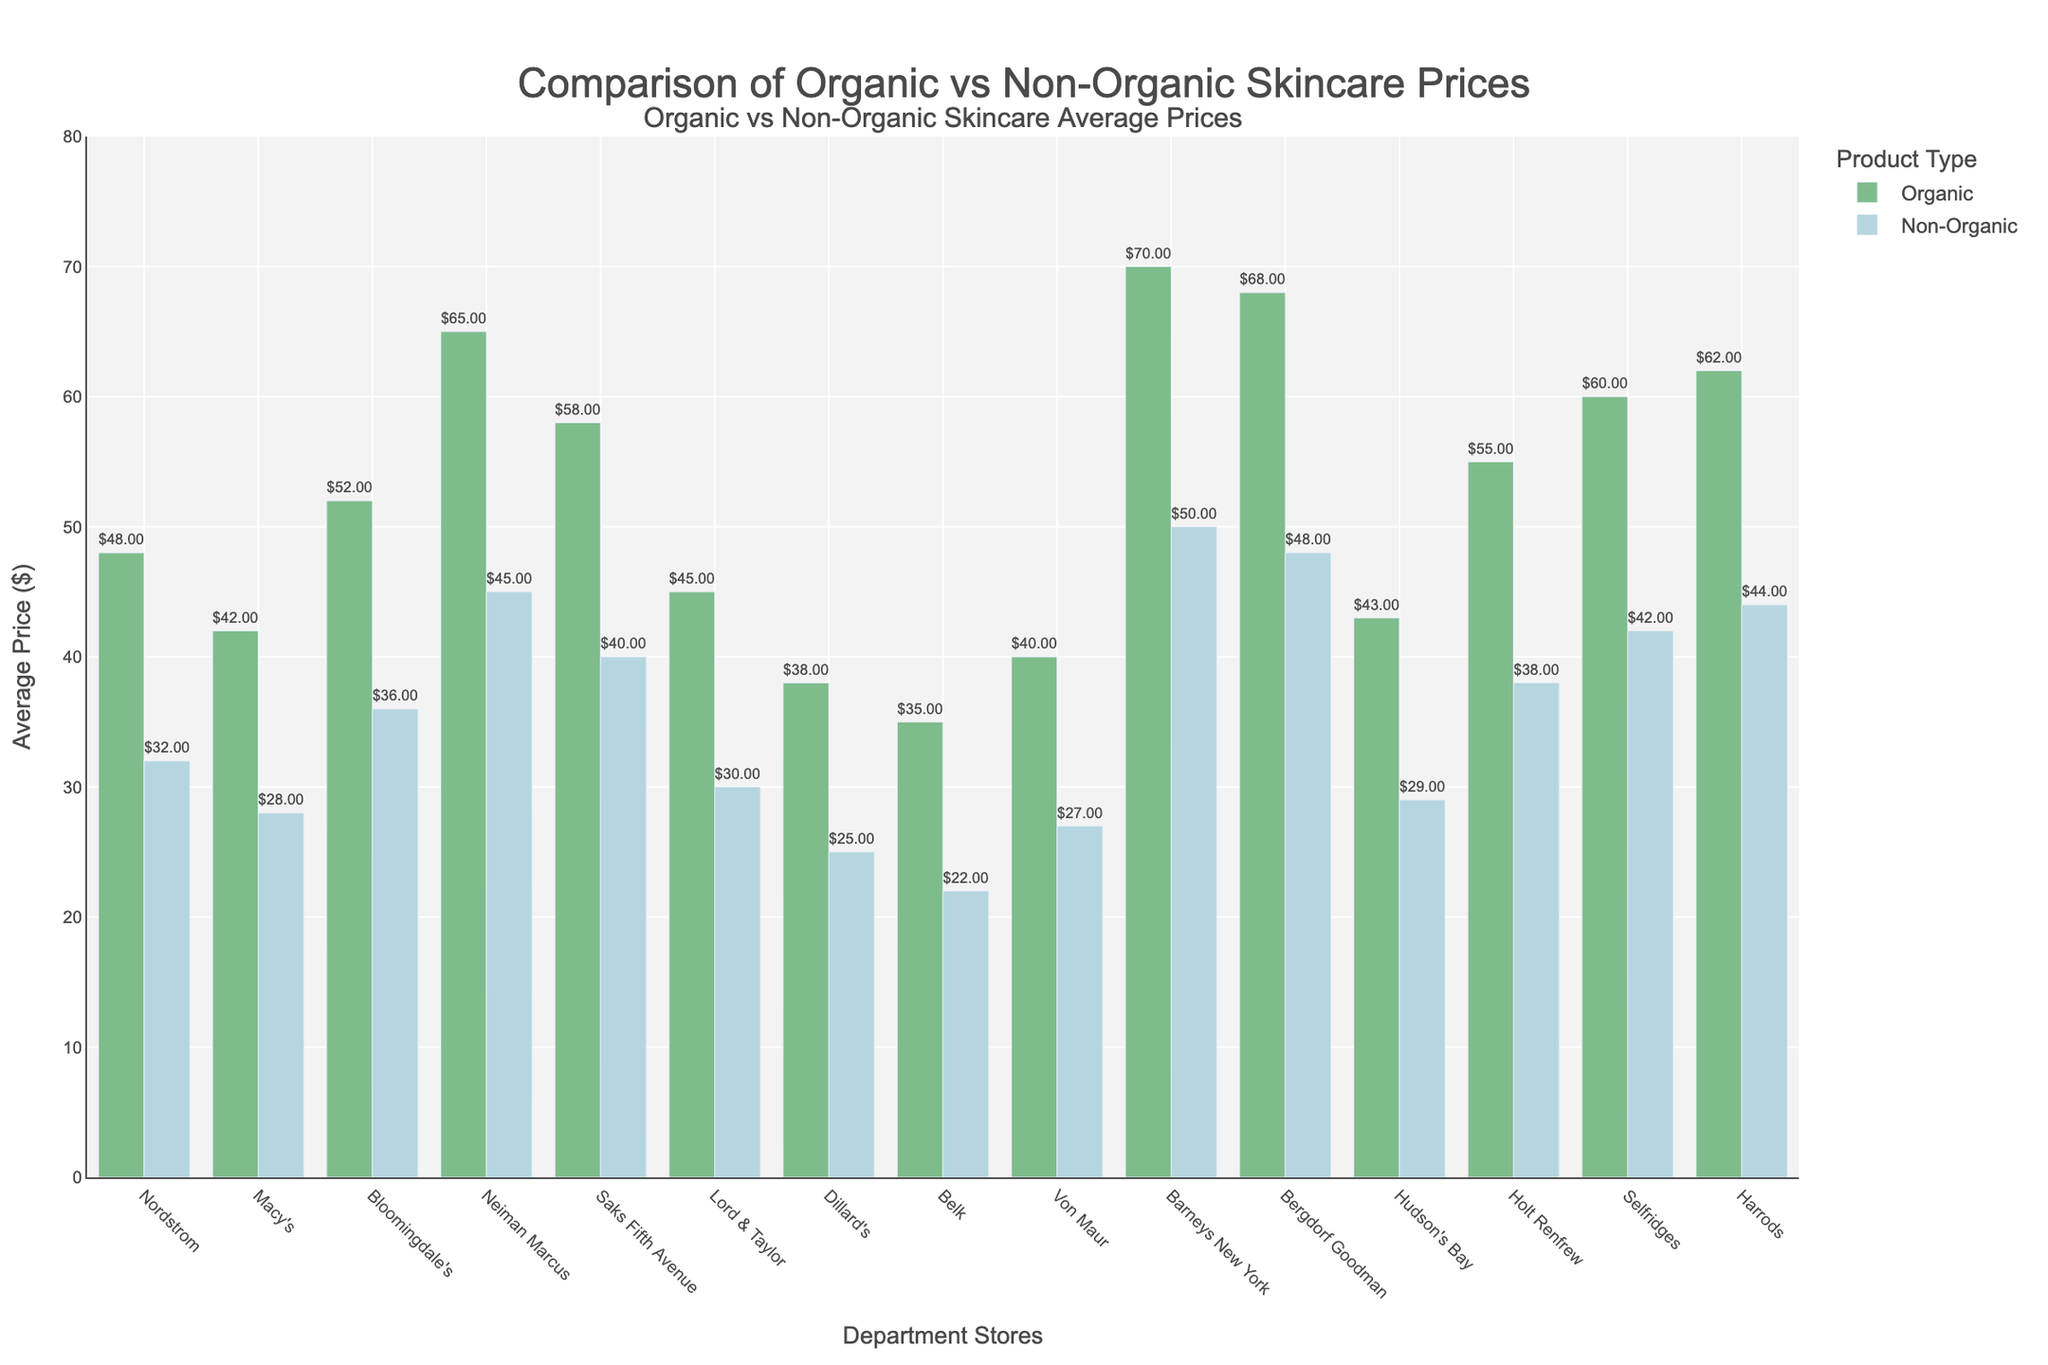What's the difference in average price between organic and non-organic skincare at Harrods? The price of organic skincare at Harrods is $62 and non-organic skincare is $44. The difference is calculated as $62 - $44 = $18.
Answer: $18 Which store has the highest average price for organic skincare products? Barneys New York has the highest bar for organic skincare products, with an average price of $70 as shown in the chart.
Answer: Barneys New York What's the average price of organic skincare products across all stores? To find the average, sum the organic skincare prices for all stores: 48 + 42 + 52 + 65 + 58 + 45 + 38 + 35 + 40 + 70 + 68 + 43 + 55 + 60 + 62 = 781. Then divide by the number of stores: 781 / 15 = 52.07.
Answer: $52.07 Which store has the smallest difference between the average prices of organic and non-organic skincare products? Belk has the smallest difference; organic skincare is $35 and non-organic skincare is $22, making the difference $13, the smallest among all stores.
Answer: Belk What is the median average price of non-organic skincare products across all stores? List the prices of non-organic skincare products in ascending order: 22, 25, 27, 28, 29, 30, 32, 36, 38, 40, 42, 44, 45, 48, 50. The median is the middle value of this list, which is $36.
Answer: $36 Is the average price of organic skincare higher at Macy's or Bloomingdale's? Bloomingdale's has a higher average price for organic skincare ($52) compared to Macy's ($42).
Answer: Bloomingdale's By how much does the average price of non-organic skincare at Neiman Marcus exceed that at Dillard's? At Neiman Marcus, the price for non-organic skincare is $45, whereas at Dillard's, it is $25. The difference is $45 - $25 = $20.
Answer: $20 What is the total average price difference between organic and non-organic skincare for all stores combined? Sum the differences for each store: (48-32) + (42-28) + (52-36) + (65-45) + (58-40) + (45-30) + (38-25) + (35-22) + (40-27) + (70-50) + (68-48) + (43-29) + (55-38) + (60-42) + (62-44) = 16 + 14 + 16 + 20 + 18 + 15 + 13 + 13 + 13 + 20 + 20 + 14 + 17 + 18 + 18 = 245.
Answer: $245 